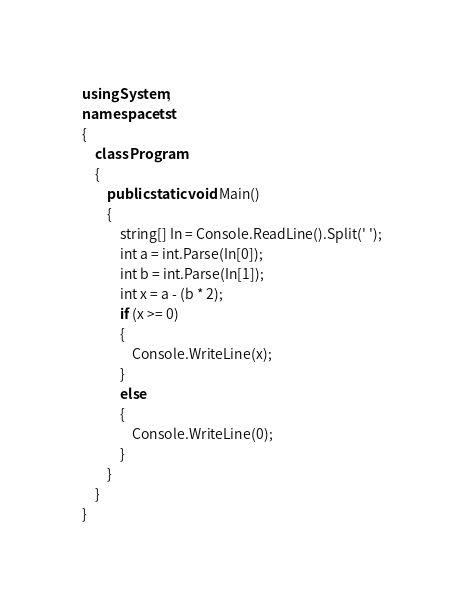Convert code to text. <code><loc_0><loc_0><loc_500><loc_500><_C#_>using System;
namespace tst
{
    class Program
    {
        public static void Main()
        {
            string[] In = Console.ReadLine().Split(' ');
            int a = int.Parse(In[0]);
            int b = int.Parse(In[1]);
            int x = a - (b * 2);
            if (x >= 0)
            {
                Console.WriteLine(x);
            }
            else
            {
                Console.WriteLine(0);
            }
        }
    }
}</code> 